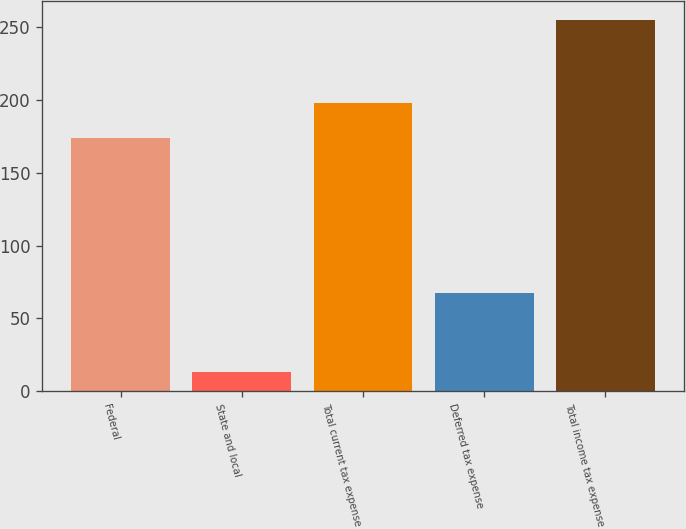Convert chart to OTSL. <chart><loc_0><loc_0><loc_500><loc_500><bar_chart><fcel>Federal<fcel>State and local<fcel>Total current tax expense<fcel>Deferred tax expense<fcel>Total income tax expense<nl><fcel>173.9<fcel>13.5<fcel>198.07<fcel>67.8<fcel>255.2<nl></chart> 